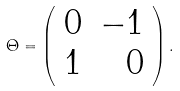Convert formula to latex. <formula><loc_0><loc_0><loc_500><loc_500>\Theta = \left ( \begin{array} { r r } 0 & - 1 \\ 1 & 0 \end{array} \right ) .</formula> 